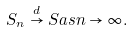<formula> <loc_0><loc_0><loc_500><loc_500>S _ { n } \stackrel { d } { \to } S a s n \to \infty .</formula> 